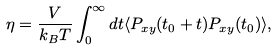<formula> <loc_0><loc_0><loc_500><loc_500>\eta = \frac { V } { k _ { B } T } \int _ { 0 } ^ { \infty } d t \langle P _ { x y } ( t _ { 0 } + t ) P _ { x y } ( t _ { 0 } ) \rangle ,</formula> 